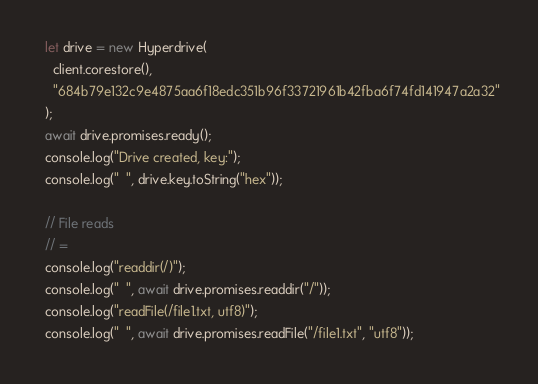Convert code to text. <code><loc_0><loc_0><loc_500><loc_500><_JavaScript_>  let drive = new Hyperdrive(
    client.corestore(),
    "684b79e132c9e4875aa6f18edc351b96f33721961b42fba6f74fd141947a2a32"
  );
  await drive.promises.ready();
  console.log("Drive created, key:");
  console.log("  ", drive.key.toString("hex"));

  // File reads
  // =
  console.log("readdir(/)");
  console.log("  ", await drive.promises.readdir("/"));
  console.log("readFile(/file1.txt, utf8)");
  console.log("  ", await drive.promises.readFile("/file1.txt", "utf8"));</code> 